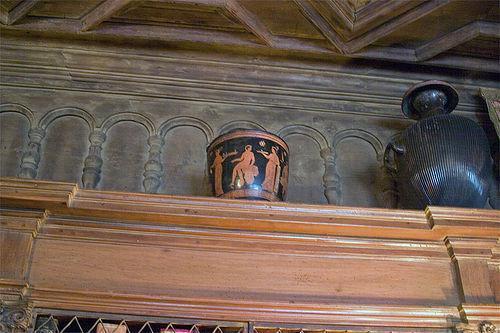How many black vases are there?
Give a very brief answer. 1. How many vases can you see?
Give a very brief answer. 2. How many people are holding camera?
Give a very brief answer. 0. 